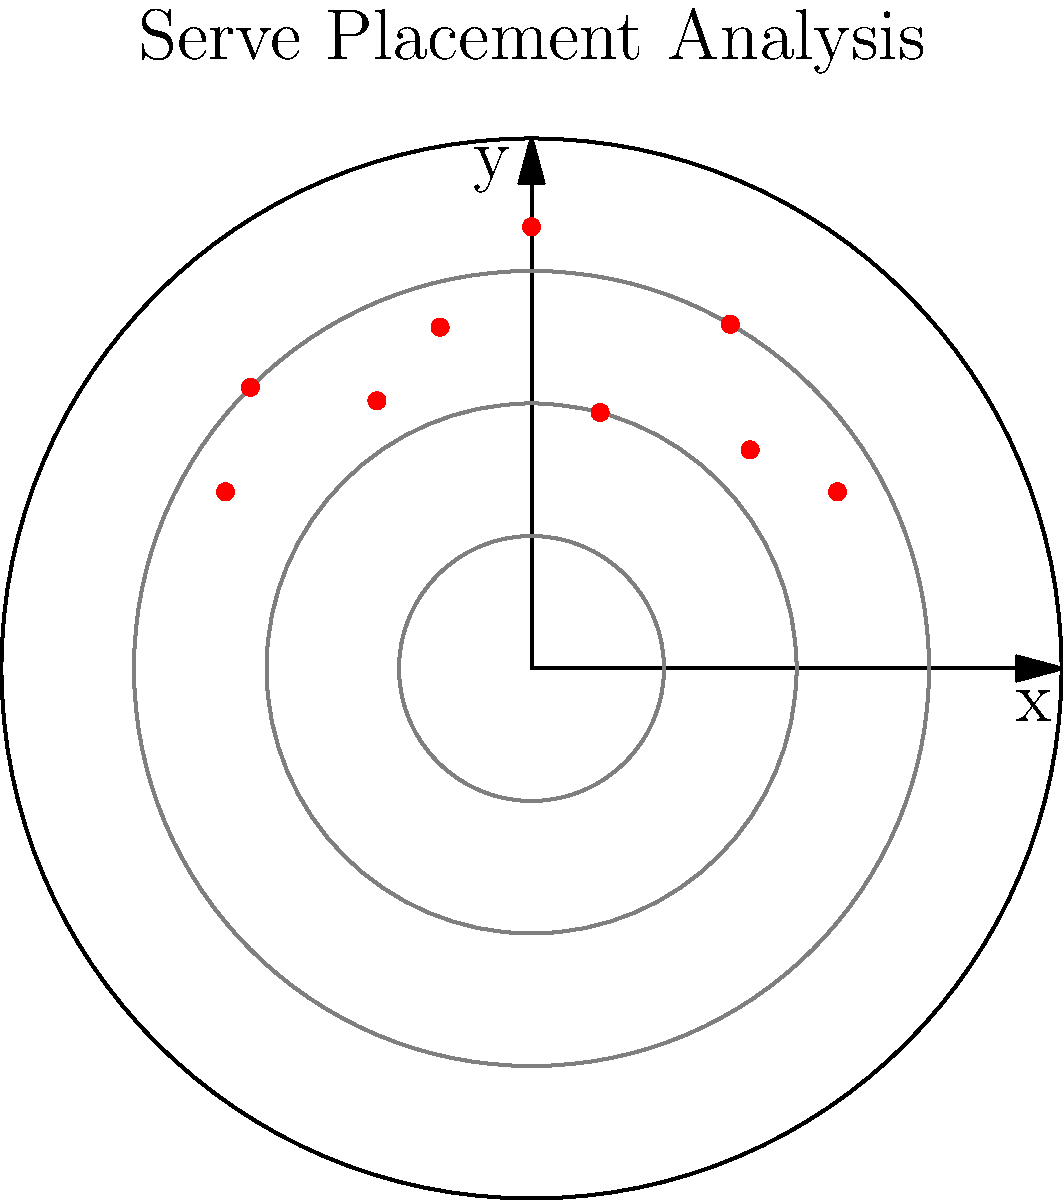A local tennis player's serve placements have been tracked and plotted on a polar coordinate system, where the distance from the center represents the serve's speed in meters per second, and the angle represents the direction of the serve. If the average serve speed is 8 m/s, in which quadrant does the player tend to serve with above-average speed most frequently? To solve this problem, we need to follow these steps:

1. Understand the polar coordinate system:
   - The center represents the server's position.
   - The angle represents the direction of the serve.
   - The distance from the center represents the serve speed.

2. Identify the quadrants:
   - Quadrant I: 0° to 90°
   - Quadrant II: 90° to 180°
   - Quadrant III: 180° to 270°
   - Quadrant IV: 270° to 360°

3. Analyze the data points:
   - Count the number of serves in each quadrant with speed > 8 m/s.
   - Quadrant I (0° to 90°):
     30°: 8 m/s, 45°: 7 m/s, 60°: 9 m/s, 75°: 6 m/s, 90°: 10 m/s
     Above average: 2 (60° and 90°)
   - Quadrant II (90° to 180°):
     105°: 8 m/s, 120°: 7 m/s, 135°: 9 m/s, 150°: 8 m/s
     Above average: 1 (135°)

4. Compare the results:
   Quadrant I has the most serves above average speed (2), while Quadrant II has only 1.
   Quadrants III and IV have no data points in this set.

5. Conclude:
   The player tends to serve with above-average speed most frequently in Quadrant I.
Answer: Quadrant I 